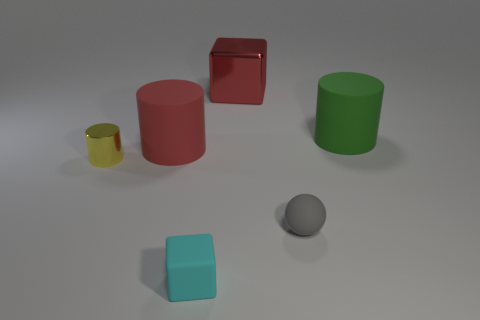What number of green things are tiny spheres or small objects?
Provide a short and direct response. 0. There is a red thing that is made of the same material as the small cyan block; what size is it?
Your answer should be compact. Large. How many cyan matte things have the same shape as the big red matte thing?
Make the answer very short. 0. Is the number of small cyan matte cubes that are to the right of the tiny yellow cylinder greater than the number of small yellow metal objects that are to the right of the green rubber cylinder?
Your response must be concise. Yes. There is a matte cube; is it the same color as the small rubber thing that is behind the small cyan object?
Make the answer very short. No. What material is the gray sphere that is the same size as the matte block?
Make the answer very short. Rubber. How many things are either small matte balls or large matte cylinders that are on the left side of the small cyan cube?
Keep it short and to the point. 2. There is a green matte cylinder; does it have the same size as the block in front of the big metallic block?
Your answer should be very brief. No. What number of balls are big metal objects or big green rubber things?
Your answer should be very brief. 0. How many cubes are both in front of the large red rubber thing and behind the tiny rubber block?
Keep it short and to the point. 0. 